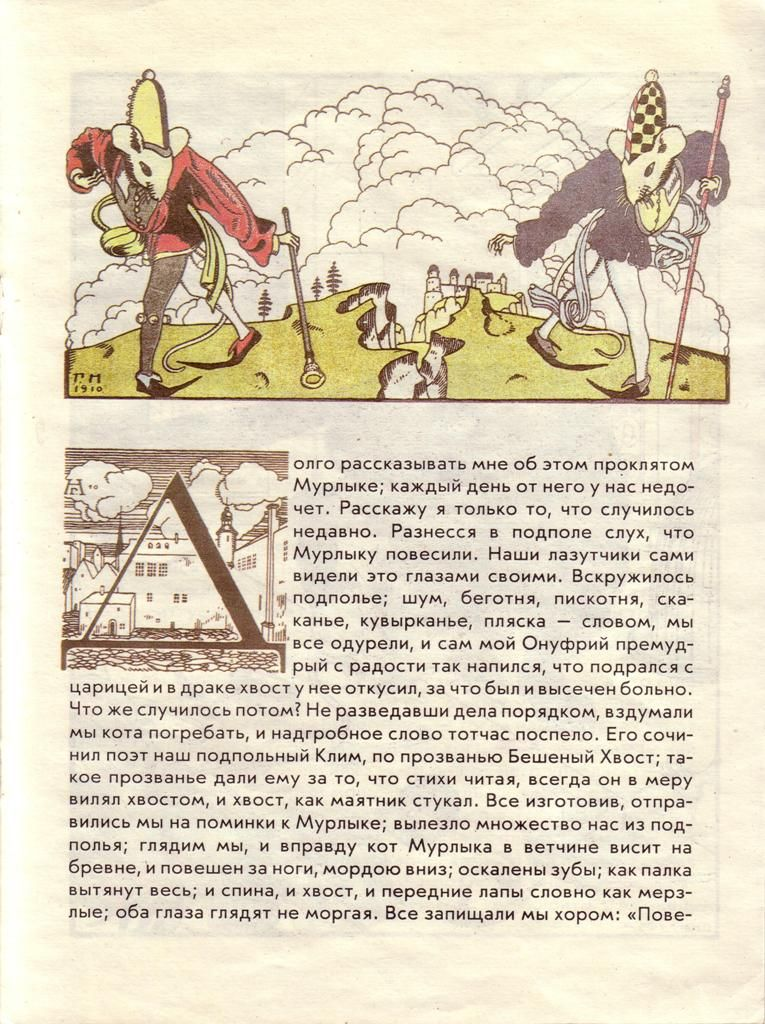What might be the significance of the exaggerated features and style in this illustration? The exaggerated features and playful style likely serve to inject humor and satire into the depiction. Such caricatures often aim to highlight certain traits or behaviors by amplifying them to absurd proportions. In historical contexts, exaggerations can also make characters or scenarios more memorable and engaging for the audience, possibly critiquing or lampooning the depicted figures or the era itself. 